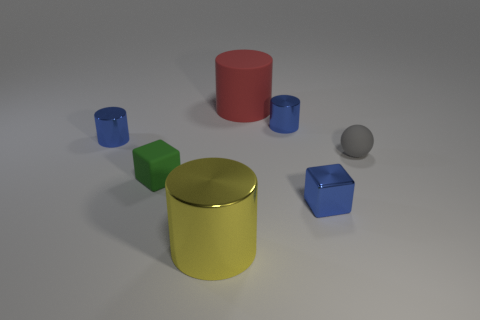Subtract 1 cylinders. How many cylinders are left? 3 Add 1 big cyan objects. How many objects exist? 8 Subtract all cubes. How many objects are left? 5 Subtract 0 blue balls. How many objects are left? 7 Subtract all big red metal cylinders. Subtract all blocks. How many objects are left? 5 Add 4 green objects. How many green objects are left? 5 Add 6 cyan metallic blocks. How many cyan metallic blocks exist? 6 